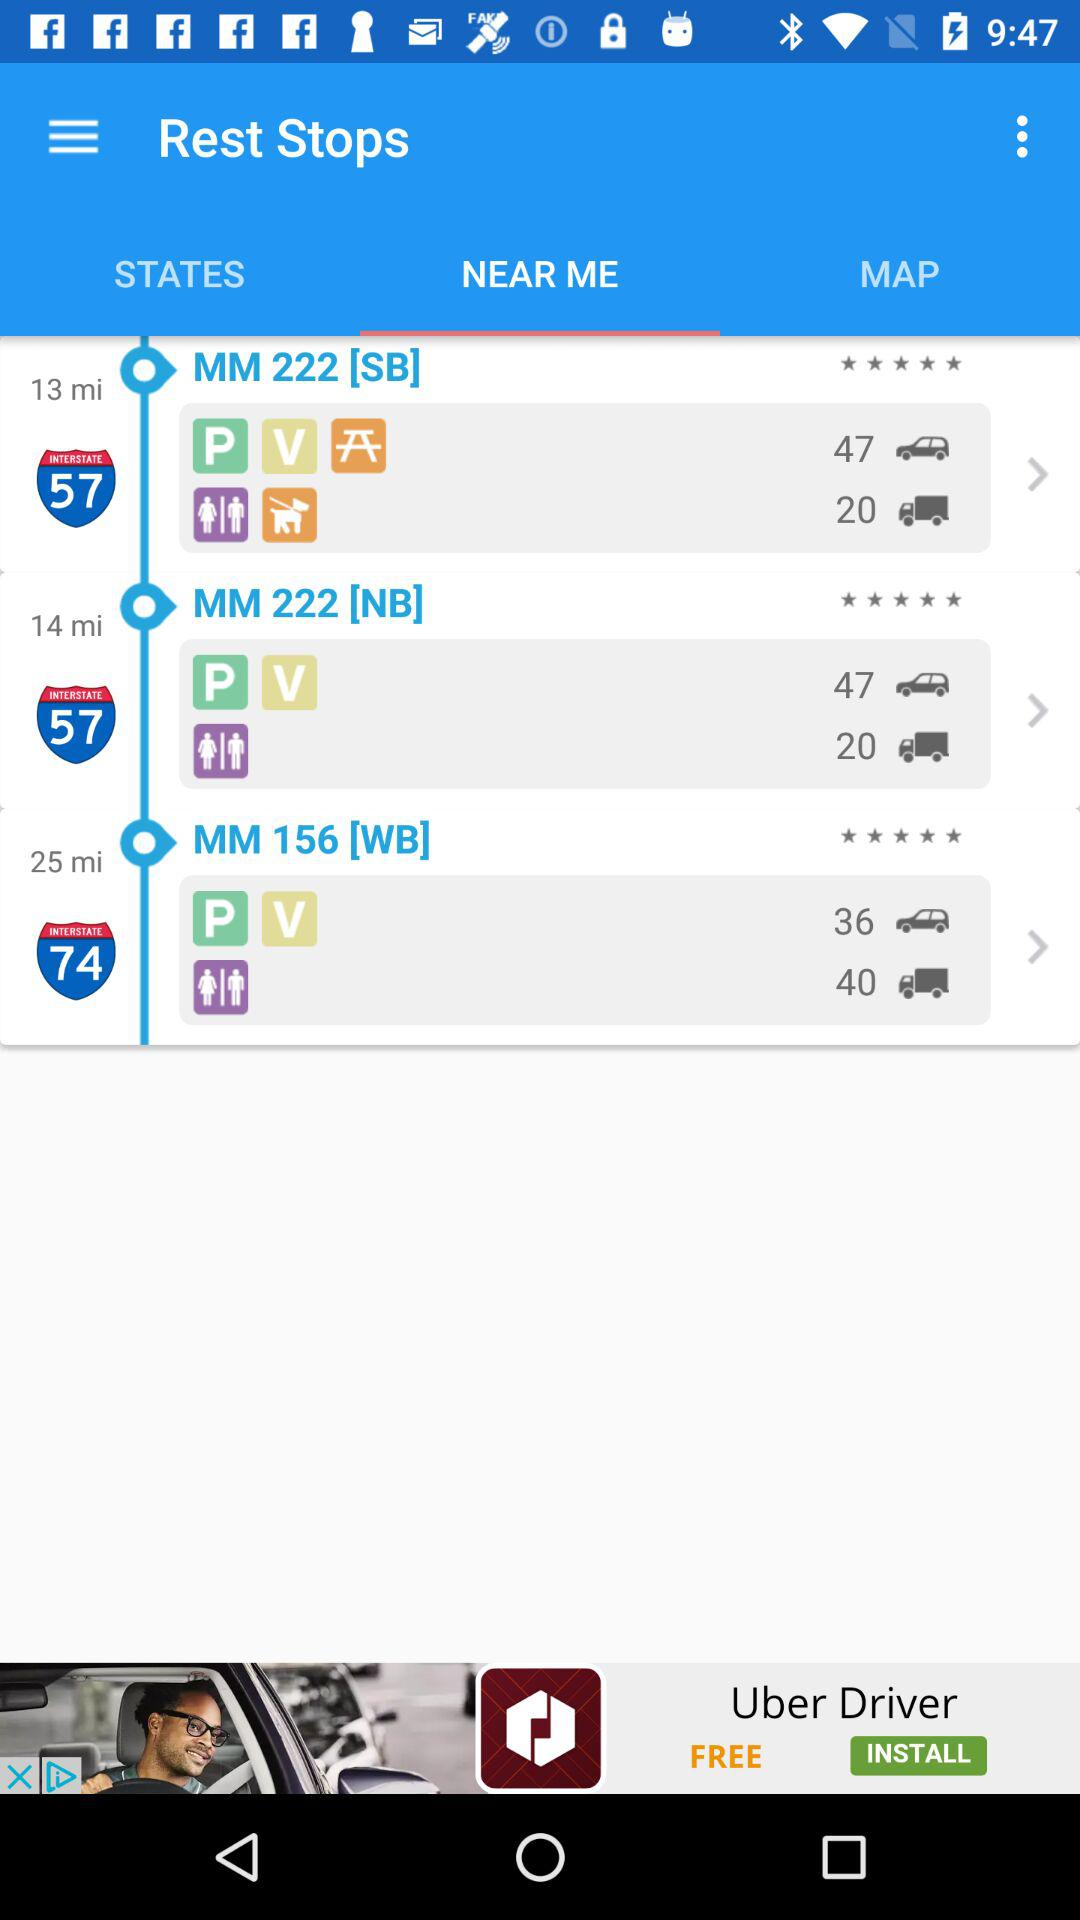What is the rating for "MM 156 [WB]"? The rating for "MM 156 [WB]" is 5 stars. 